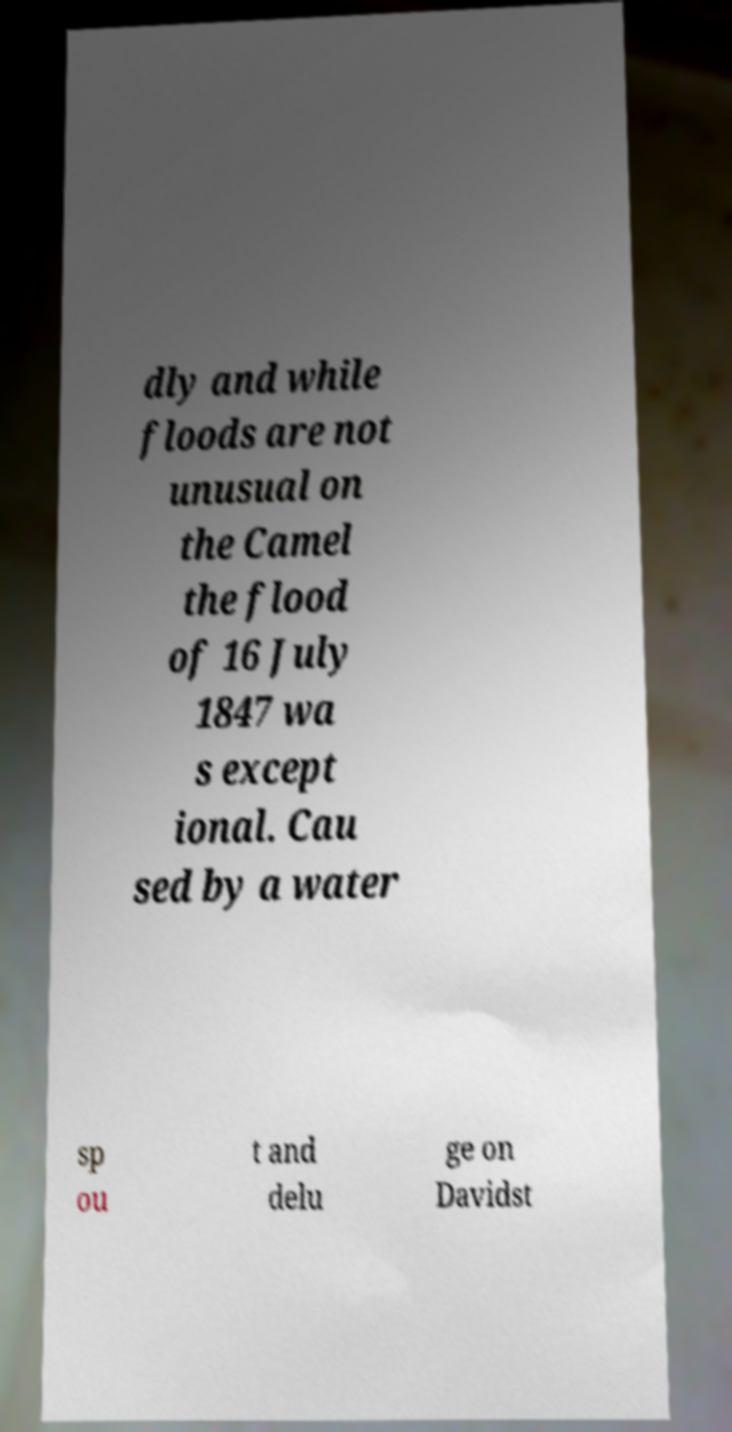Can you accurately transcribe the text from the provided image for me? dly and while floods are not unusual on the Camel the flood of 16 July 1847 wa s except ional. Cau sed by a water sp ou t and delu ge on Davidst 